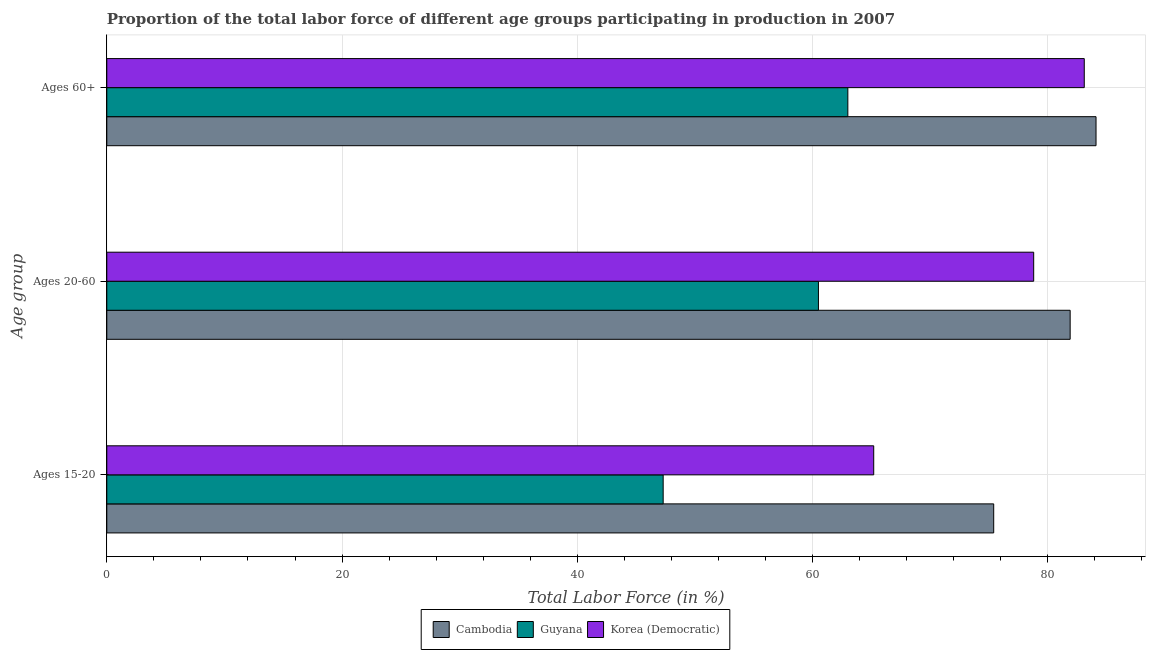How many different coloured bars are there?
Make the answer very short. 3. Are the number of bars per tick equal to the number of legend labels?
Your response must be concise. Yes. Are the number of bars on each tick of the Y-axis equal?
Your answer should be very brief. Yes. How many bars are there on the 1st tick from the top?
Provide a succinct answer. 3. What is the label of the 3rd group of bars from the top?
Offer a very short reply. Ages 15-20. What is the percentage of labor force within the age group 15-20 in Korea (Democratic)?
Keep it short and to the point. 65.2. Across all countries, what is the maximum percentage of labor force above age 60?
Keep it short and to the point. 84.1. Across all countries, what is the minimum percentage of labor force within the age group 15-20?
Make the answer very short. 47.3. In which country was the percentage of labor force within the age group 20-60 maximum?
Give a very brief answer. Cambodia. In which country was the percentage of labor force above age 60 minimum?
Your response must be concise. Guyana. What is the total percentage of labor force within the age group 20-60 in the graph?
Keep it short and to the point. 221.2. What is the difference between the percentage of labor force within the age group 15-20 in Guyana and that in Korea (Democratic)?
Provide a succinct answer. -17.9. What is the difference between the percentage of labor force above age 60 in Cambodia and the percentage of labor force within the age group 15-20 in Korea (Democratic)?
Ensure brevity in your answer.  18.9. What is the average percentage of labor force within the age group 15-20 per country?
Provide a short and direct response. 62.63. What is the difference between the percentage of labor force within the age group 20-60 and percentage of labor force within the age group 15-20 in Korea (Democratic)?
Make the answer very short. 13.6. In how many countries, is the percentage of labor force above age 60 greater than 80 %?
Give a very brief answer. 2. What is the ratio of the percentage of labor force within the age group 15-20 in Cambodia to that in Guyana?
Offer a very short reply. 1.59. Is the difference between the percentage of labor force within the age group 15-20 in Guyana and Korea (Democratic) greater than the difference between the percentage of labor force within the age group 20-60 in Guyana and Korea (Democratic)?
Keep it short and to the point. Yes. What is the difference between the highest and the second highest percentage of labor force within the age group 15-20?
Provide a succinct answer. 10.2. What is the difference between the highest and the lowest percentage of labor force within the age group 20-60?
Your answer should be very brief. 21.4. Is the sum of the percentage of labor force within the age group 15-20 in Cambodia and Korea (Democratic) greater than the maximum percentage of labor force above age 60 across all countries?
Keep it short and to the point. Yes. What does the 2nd bar from the top in Ages 20-60 represents?
Provide a succinct answer. Guyana. What does the 1st bar from the bottom in Ages 20-60 represents?
Ensure brevity in your answer.  Cambodia. Is it the case that in every country, the sum of the percentage of labor force within the age group 15-20 and percentage of labor force within the age group 20-60 is greater than the percentage of labor force above age 60?
Make the answer very short. Yes. How many bars are there?
Your answer should be compact. 9. Are all the bars in the graph horizontal?
Your answer should be very brief. Yes. What is the difference between two consecutive major ticks on the X-axis?
Provide a short and direct response. 20. Are the values on the major ticks of X-axis written in scientific E-notation?
Your response must be concise. No. Does the graph contain any zero values?
Keep it short and to the point. No. Does the graph contain grids?
Provide a succinct answer. Yes. Where does the legend appear in the graph?
Offer a terse response. Bottom center. How many legend labels are there?
Your response must be concise. 3. How are the legend labels stacked?
Give a very brief answer. Horizontal. What is the title of the graph?
Your answer should be compact. Proportion of the total labor force of different age groups participating in production in 2007. Does "Germany" appear as one of the legend labels in the graph?
Your response must be concise. No. What is the label or title of the X-axis?
Make the answer very short. Total Labor Force (in %). What is the label or title of the Y-axis?
Give a very brief answer. Age group. What is the Total Labor Force (in %) in Cambodia in Ages 15-20?
Make the answer very short. 75.4. What is the Total Labor Force (in %) of Guyana in Ages 15-20?
Your answer should be compact. 47.3. What is the Total Labor Force (in %) of Korea (Democratic) in Ages 15-20?
Your answer should be compact. 65.2. What is the Total Labor Force (in %) of Cambodia in Ages 20-60?
Make the answer very short. 81.9. What is the Total Labor Force (in %) of Guyana in Ages 20-60?
Your answer should be compact. 60.5. What is the Total Labor Force (in %) in Korea (Democratic) in Ages 20-60?
Offer a very short reply. 78.8. What is the Total Labor Force (in %) in Cambodia in Ages 60+?
Provide a succinct answer. 84.1. What is the Total Labor Force (in %) of Korea (Democratic) in Ages 60+?
Provide a succinct answer. 83.1. Across all Age group, what is the maximum Total Labor Force (in %) of Cambodia?
Provide a short and direct response. 84.1. Across all Age group, what is the maximum Total Labor Force (in %) of Guyana?
Offer a very short reply. 63. Across all Age group, what is the maximum Total Labor Force (in %) in Korea (Democratic)?
Keep it short and to the point. 83.1. Across all Age group, what is the minimum Total Labor Force (in %) in Cambodia?
Give a very brief answer. 75.4. Across all Age group, what is the minimum Total Labor Force (in %) in Guyana?
Provide a succinct answer. 47.3. Across all Age group, what is the minimum Total Labor Force (in %) in Korea (Democratic)?
Keep it short and to the point. 65.2. What is the total Total Labor Force (in %) in Cambodia in the graph?
Your answer should be compact. 241.4. What is the total Total Labor Force (in %) in Guyana in the graph?
Make the answer very short. 170.8. What is the total Total Labor Force (in %) in Korea (Democratic) in the graph?
Your answer should be compact. 227.1. What is the difference between the Total Labor Force (in %) in Cambodia in Ages 15-20 and that in Ages 20-60?
Keep it short and to the point. -6.5. What is the difference between the Total Labor Force (in %) of Guyana in Ages 15-20 and that in Ages 20-60?
Give a very brief answer. -13.2. What is the difference between the Total Labor Force (in %) in Guyana in Ages 15-20 and that in Ages 60+?
Provide a short and direct response. -15.7. What is the difference between the Total Labor Force (in %) in Korea (Democratic) in Ages 15-20 and that in Ages 60+?
Make the answer very short. -17.9. What is the difference between the Total Labor Force (in %) in Cambodia in Ages 15-20 and the Total Labor Force (in %) in Guyana in Ages 20-60?
Offer a very short reply. 14.9. What is the difference between the Total Labor Force (in %) in Guyana in Ages 15-20 and the Total Labor Force (in %) in Korea (Democratic) in Ages 20-60?
Keep it short and to the point. -31.5. What is the difference between the Total Labor Force (in %) of Guyana in Ages 15-20 and the Total Labor Force (in %) of Korea (Democratic) in Ages 60+?
Your response must be concise. -35.8. What is the difference between the Total Labor Force (in %) of Cambodia in Ages 20-60 and the Total Labor Force (in %) of Guyana in Ages 60+?
Make the answer very short. 18.9. What is the difference between the Total Labor Force (in %) in Cambodia in Ages 20-60 and the Total Labor Force (in %) in Korea (Democratic) in Ages 60+?
Provide a short and direct response. -1.2. What is the difference between the Total Labor Force (in %) in Guyana in Ages 20-60 and the Total Labor Force (in %) in Korea (Democratic) in Ages 60+?
Offer a terse response. -22.6. What is the average Total Labor Force (in %) in Cambodia per Age group?
Offer a very short reply. 80.47. What is the average Total Labor Force (in %) of Guyana per Age group?
Your answer should be very brief. 56.93. What is the average Total Labor Force (in %) of Korea (Democratic) per Age group?
Give a very brief answer. 75.7. What is the difference between the Total Labor Force (in %) in Cambodia and Total Labor Force (in %) in Guyana in Ages 15-20?
Offer a terse response. 28.1. What is the difference between the Total Labor Force (in %) of Guyana and Total Labor Force (in %) of Korea (Democratic) in Ages 15-20?
Your answer should be compact. -17.9. What is the difference between the Total Labor Force (in %) in Cambodia and Total Labor Force (in %) in Guyana in Ages 20-60?
Your response must be concise. 21.4. What is the difference between the Total Labor Force (in %) in Guyana and Total Labor Force (in %) in Korea (Democratic) in Ages 20-60?
Keep it short and to the point. -18.3. What is the difference between the Total Labor Force (in %) of Cambodia and Total Labor Force (in %) of Guyana in Ages 60+?
Ensure brevity in your answer.  21.1. What is the difference between the Total Labor Force (in %) of Guyana and Total Labor Force (in %) of Korea (Democratic) in Ages 60+?
Make the answer very short. -20.1. What is the ratio of the Total Labor Force (in %) of Cambodia in Ages 15-20 to that in Ages 20-60?
Offer a very short reply. 0.92. What is the ratio of the Total Labor Force (in %) of Guyana in Ages 15-20 to that in Ages 20-60?
Your answer should be very brief. 0.78. What is the ratio of the Total Labor Force (in %) in Korea (Democratic) in Ages 15-20 to that in Ages 20-60?
Provide a succinct answer. 0.83. What is the ratio of the Total Labor Force (in %) in Cambodia in Ages 15-20 to that in Ages 60+?
Your answer should be compact. 0.9. What is the ratio of the Total Labor Force (in %) in Guyana in Ages 15-20 to that in Ages 60+?
Your answer should be very brief. 0.75. What is the ratio of the Total Labor Force (in %) in Korea (Democratic) in Ages 15-20 to that in Ages 60+?
Make the answer very short. 0.78. What is the ratio of the Total Labor Force (in %) of Cambodia in Ages 20-60 to that in Ages 60+?
Keep it short and to the point. 0.97. What is the ratio of the Total Labor Force (in %) of Guyana in Ages 20-60 to that in Ages 60+?
Give a very brief answer. 0.96. What is the ratio of the Total Labor Force (in %) in Korea (Democratic) in Ages 20-60 to that in Ages 60+?
Offer a very short reply. 0.95. What is the difference between the highest and the second highest Total Labor Force (in %) in Cambodia?
Your answer should be compact. 2.2. What is the difference between the highest and the second highest Total Labor Force (in %) of Guyana?
Provide a succinct answer. 2.5. What is the difference between the highest and the second highest Total Labor Force (in %) of Korea (Democratic)?
Offer a very short reply. 4.3. What is the difference between the highest and the lowest Total Labor Force (in %) in Cambodia?
Provide a short and direct response. 8.7. What is the difference between the highest and the lowest Total Labor Force (in %) of Guyana?
Your answer should be compact. 15.7. What is the difference between the highest and the lowest Total Labor Force (in %) of Korea (Democratic)?
Keep it short and to the point. 17.9. 